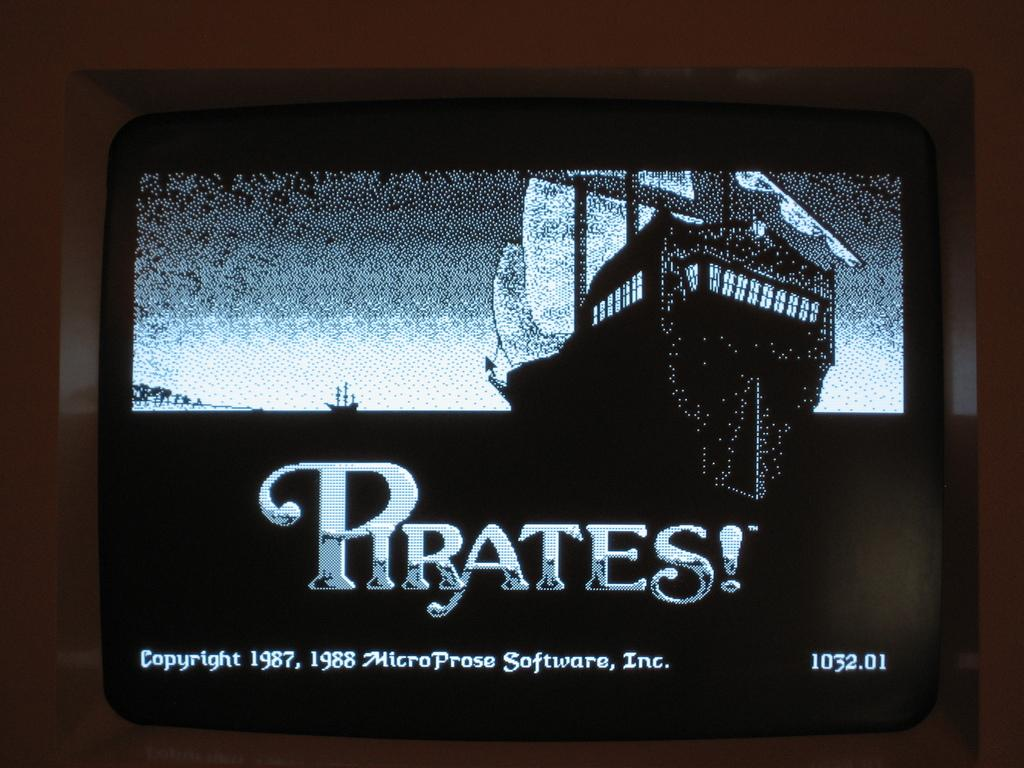What is the main object in the image? There is a screen in the image. What is being displayed on the screen? There are ships visible on the screen. Is there any text present on the screen? Yes, there is text visible on the screen. Where is the seat located in the image? There is no seat present in the image. Is there a sink visible in the image? There is no sink present in the image. Can you see a building in the image? The provided facts do not mention a building, so it cannot be determined if one is present in the image. 